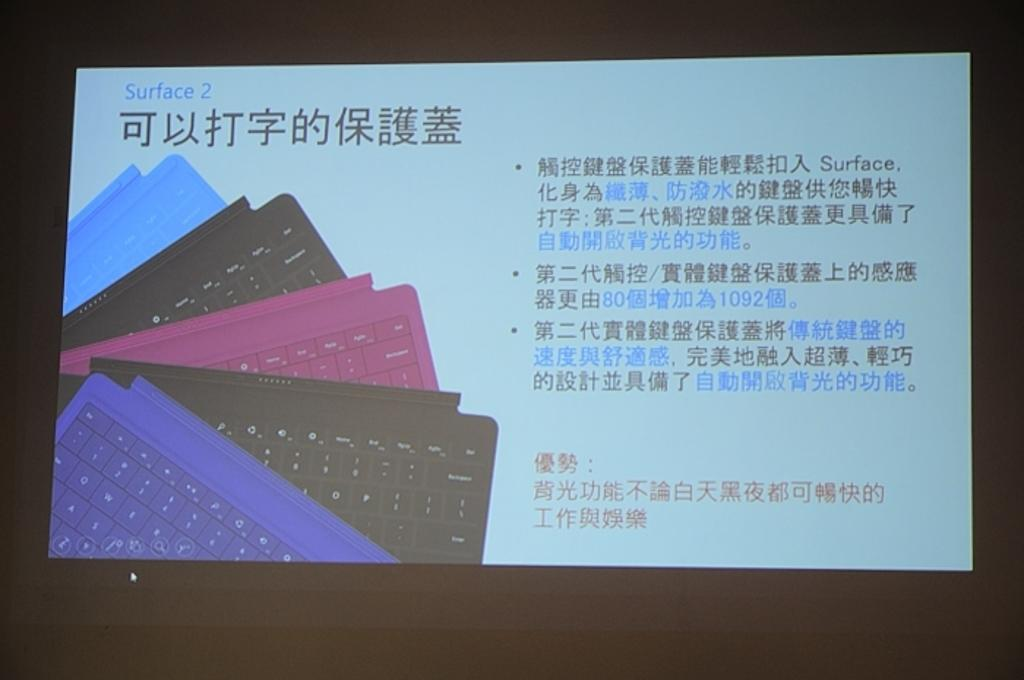<image>
Share a concise interpretation of the image provided. A business card with the text Surface 2 written in blue letters. 